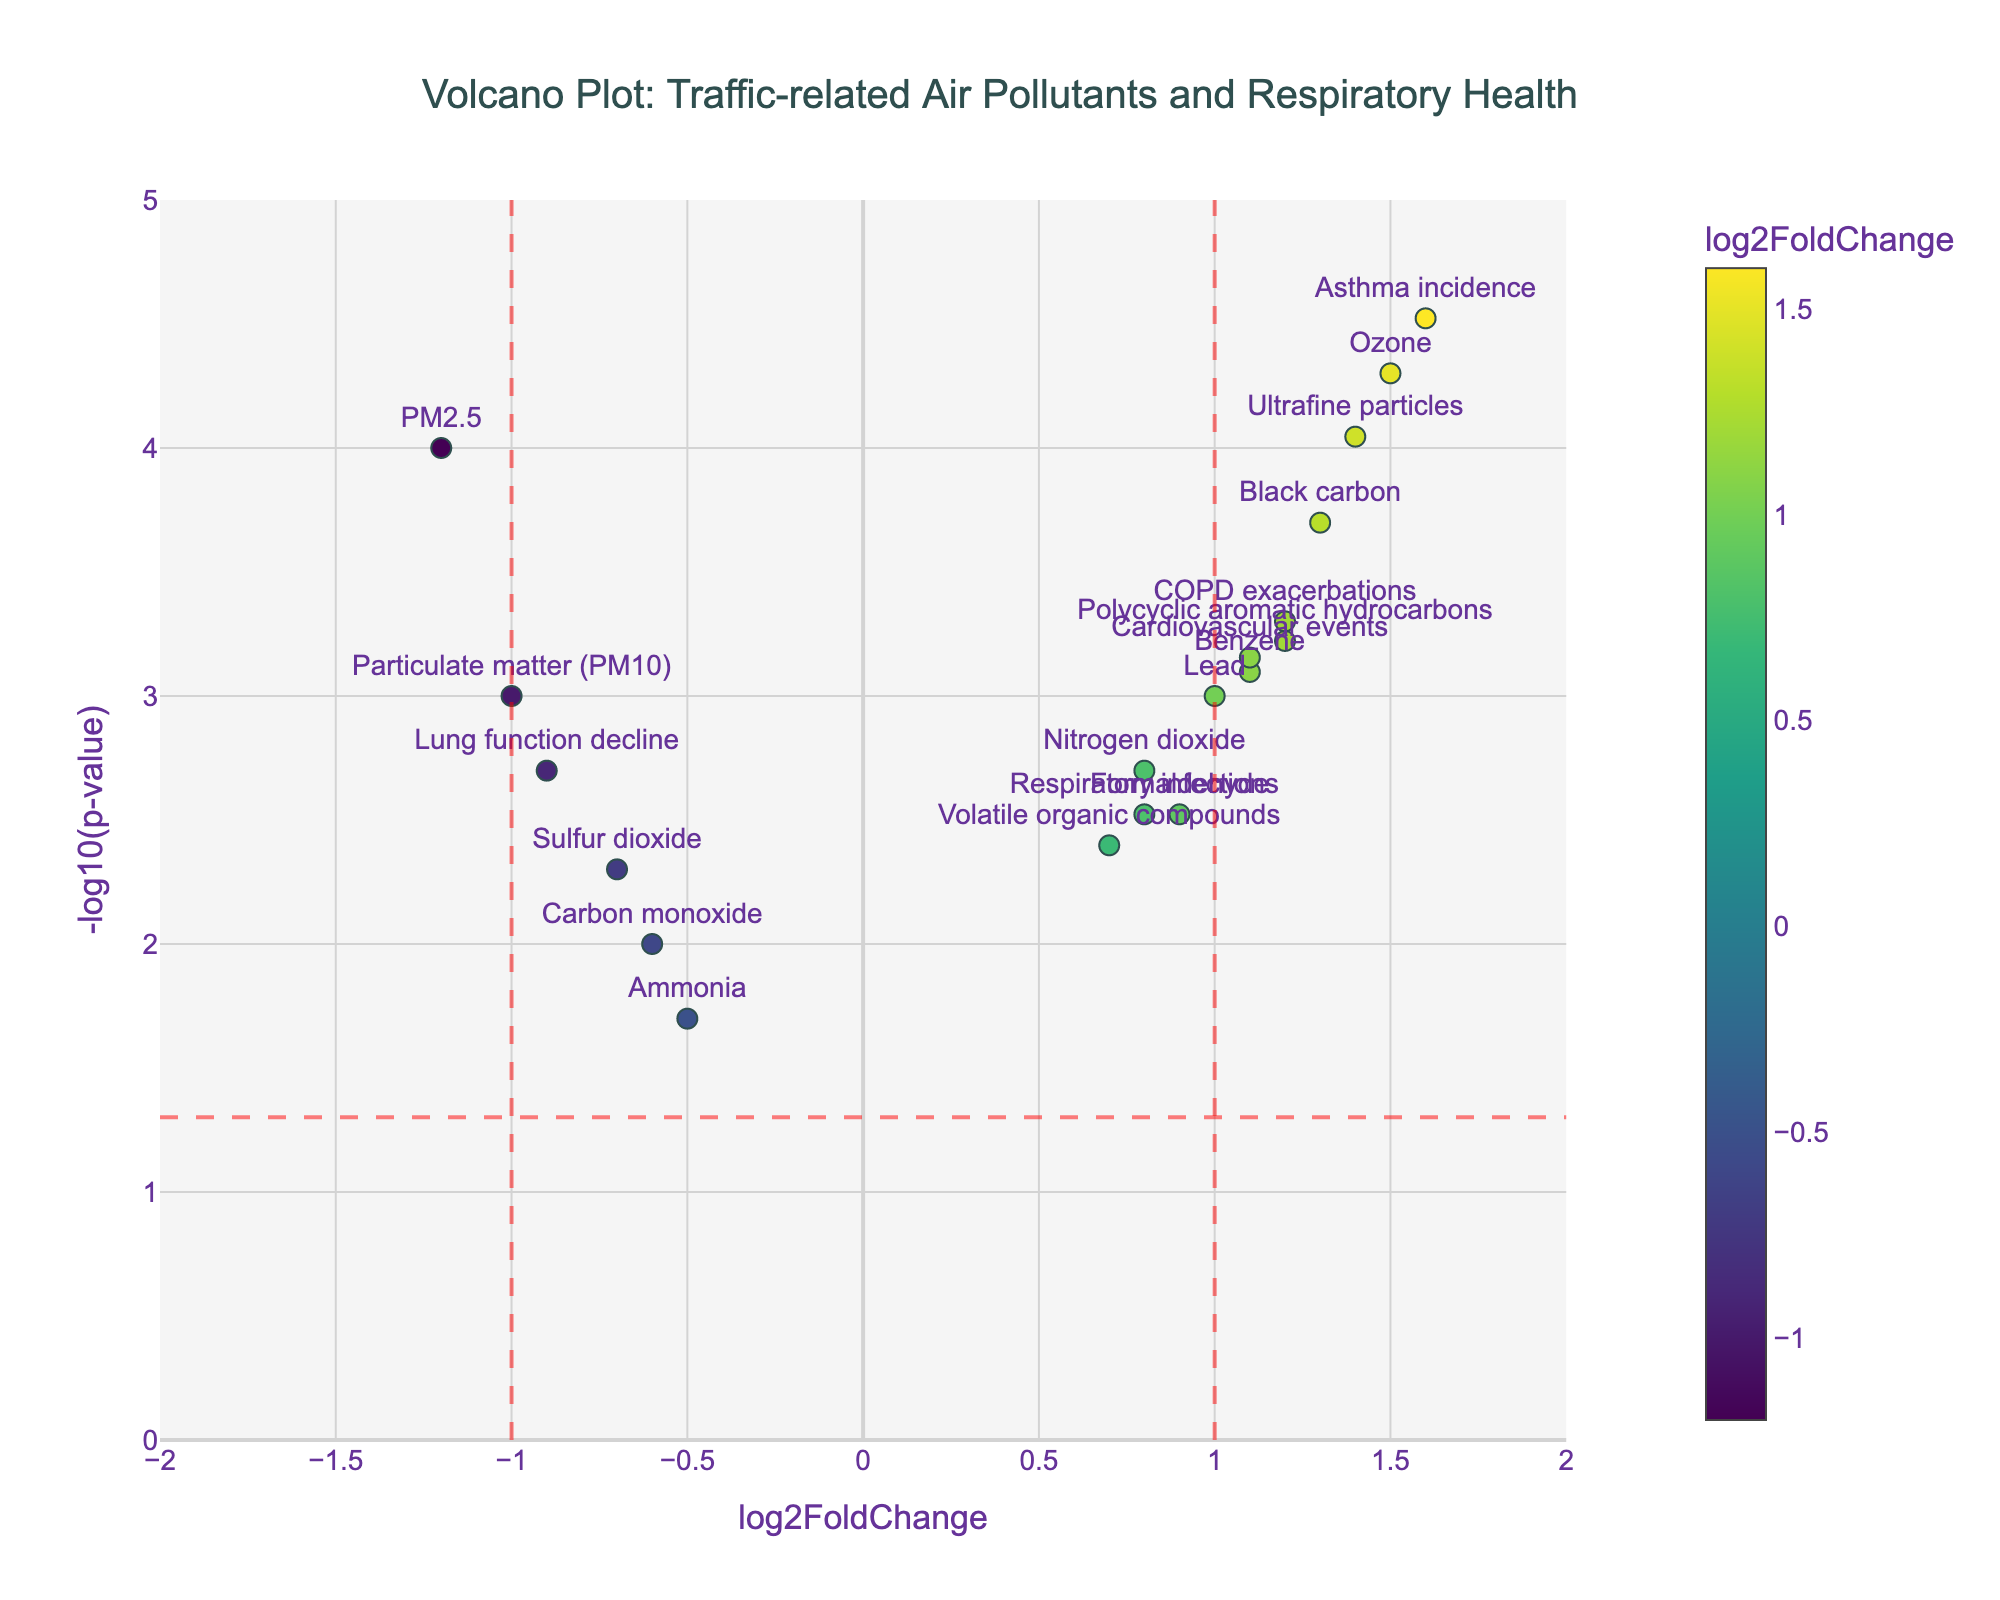What does the title of the plot indicate? The title "Volcano Plot: Traffic-related Air Pollutants and Respiratory Health" suggests that the plot shows the relationship between different traffic-related air pollutants and their impacts on respiratory health.
Answer: It indicates the relationship between traffic-related air pollutants and respiratory health What are the x-axis and y-axis representing in this plot? The x-axis represents the log2FoldChange, indicating the change in pollutant levels between high-density and low-density areas. The y-axis represents -log10(p-value), indicating the statistical significance of these changes.
Answer: x-axis: log2FoldChange, y-axis: -log10(p-value) How many pollutants have a log2FoldChange greater than 1? Look for data points with log2FoldChange greater than 1 on the x-axis. There are four such pollutants: Ozone, Black carbon, Ultrafine particles, and Asthma incidence.
Answer: Four Which pollutant has the highest level of statistical significance? The highest statistical significance corresponds to the point with the highest -log10(p-value). According to the plot, Asthma incidence has the highest value.
Answer: Asthma incidence Which pollutants have a decrease in levels in high-density areas? Pollutants with log2FoldChange less than 0 have decreased levels in high-density areas: PM2.5, Carbon monoxide, Sulfur dioxide, Particulate matter (PM10), and Ammonia.
Answer: PM2.5, Carbon monoxide, Sulfur dioxide, Particulate matter (PM10), Ammonia How does the log2FoldChange of Black carbon compare to that of Lead? Compare the log2FoldChange values of Black carbon and Lead. Black carbon has a log2FoldChange of 1.3, while Lead has 1.0, so Black carbon has a higher log2FoldChange than Lead.
Answer: Black carbon has a higher log2FoldChange What is the significance cutoff line in the plot? The horizontal red dashed line represents the significance cutoff, which is at -log10(p-value) = -log10(0.05). This is approximately 1.3.
Answer: Approximately 1.3 What is the log2FoldChange and p-value for Ozone? From the hover text on the plot, Ozone has a log2FoldChange of 1.5 and a p-value of 0.00005.
Answer: log2FoldChange: 1.5, p-value: 0.00005 How many pollutants have both high log2FoldChange and high statistical significance? High log2FoldChange is considered greater than 1, and high significance is a p-value less than 0.05. Pollutants satisfying both are Ozone, Black carbon, Ultrafine particles, and Asthma incidence.
Answer: Four Which pollutant has the lowest log2FoldChange? Look for the data point with the lowest value on the x-axis. PM2.5, having a log2FoldChange of -1.2, is the lowest.
Answer: PM2.5 